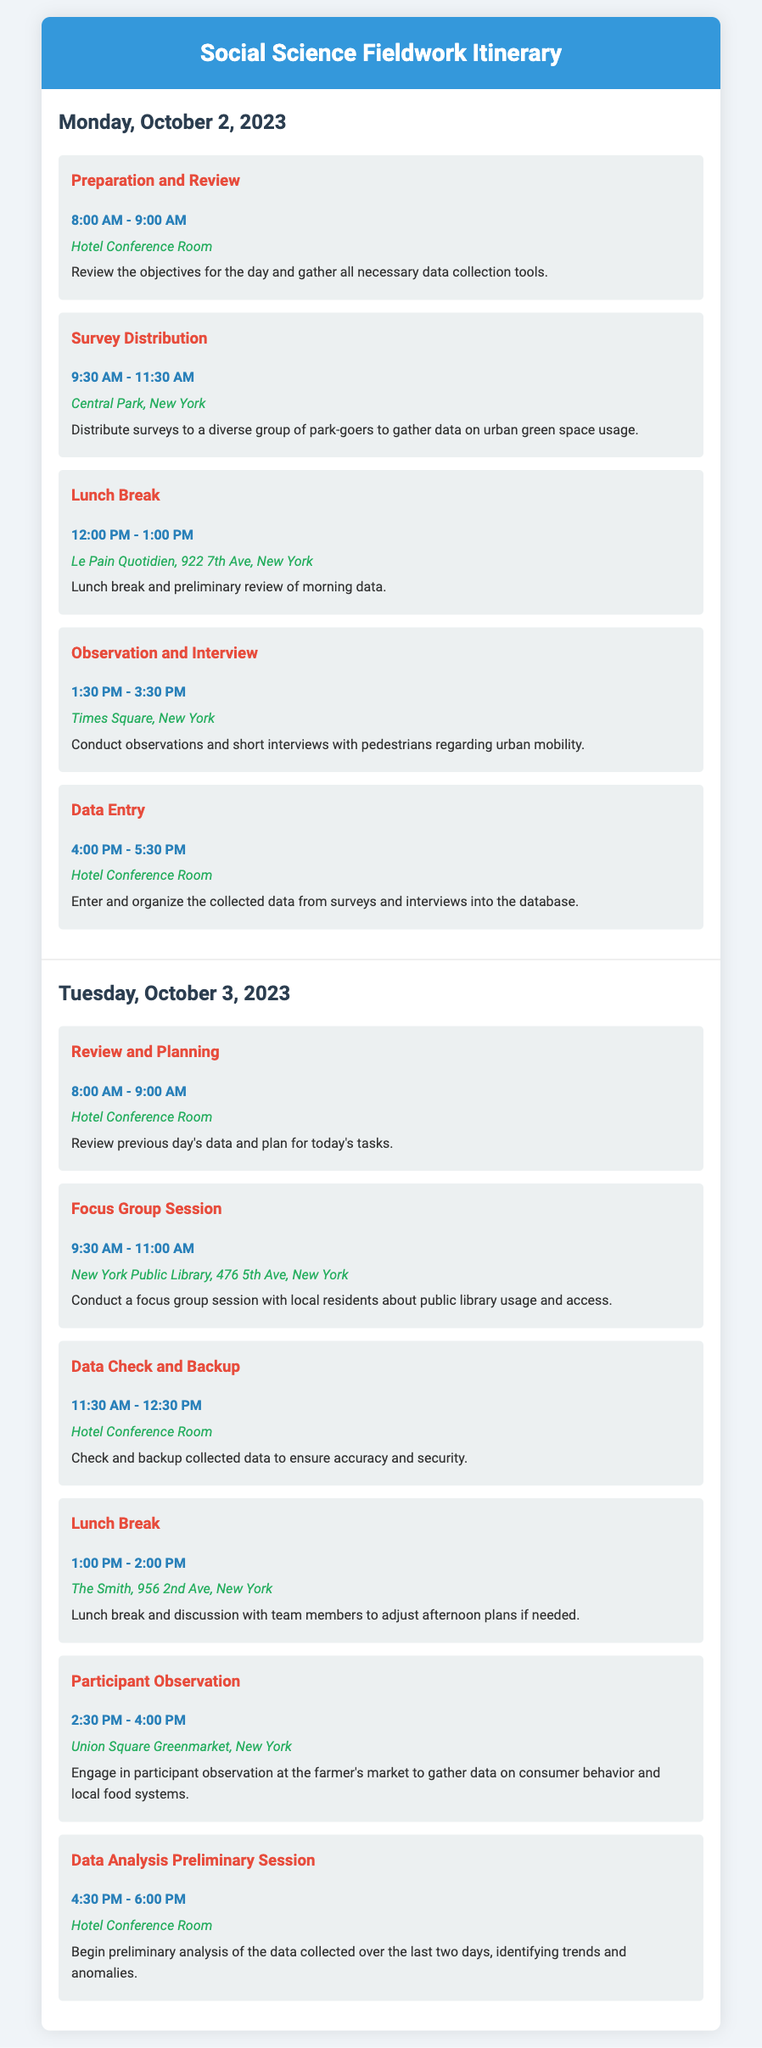What is the first activity on Monday? The first activity listed for Monday is "Preparation and Review" scheduled from 8:00 AM to 9:00 AM.
Answer: Preparation and Review What location is associated with the focus group session? The focus group session is scheduled at the New York Public Library, as indicated in the itinerary.
Answer: New York Public Library What time does the observation and interview activity start? According to the document, the "Observation and Interview" activity starts at 1:30 PM on Monday.
Answer: 1:30 PM How long is the lunch break on Tuesday? The lunch break on Tuesday is scheduled for one hour, from 1:00 PM to 2:00 PM, as detailed in the itinerary.
Answer: 1 hour What is the main purpose of the participant observation activity? The purpose of the "Participant Observation" activity is to gather data on consumer behavior and local food systems at the farmer's market.
Answer: Consumer behavior and local food systems What activity follows the data check and backup on Tuesday? The activity following the "Data Check and Backup" on Tuesday is the "Lunch Break."
Answer: Lunch Break How many activities are scheduled for Monday? There are five distinct activities scheduled for Monday.
Answer: Five activities Where will data entry take place on Monday? The data entry activity on Monday is scheduled to take place in the Hotel Conference Room.
Answer: Hotel Conference Room 